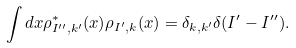<formula> <loc_0><loc_0><loc_500><loc_500>\int d { x } \rho _ { { I } ^ { \prime \prime } , { k } ^ { \prime } } ^ { * } ( { x } ) \rho _ { { I } ^ { \prime } , { k } } ( { x } ) = \delta _ { { k } , { k } ^ { \prime } } \delta ( { I } ^ { \prime } - { I } ^ { \prime \prime } ) .</formula> 